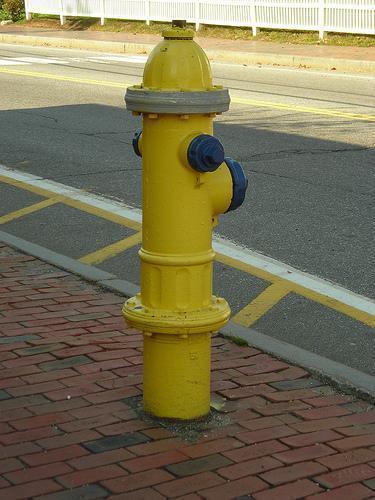How many fire hydrants are there?
Give a very brief answer. 1. 